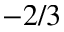Convert formula to latex. <formula><loc_0><loc_0><loc_500><loc_500>- 2 / 3</formula> 